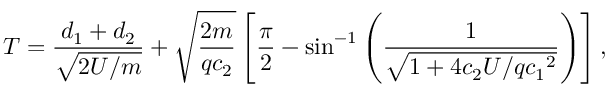Convert formula to latex. <formula><loc_0><loc_0><loc_500><loc_500>T = \frac { d _ { 1 } + d _ { 2 } } { \sqrt { 2 U / m } } + \sqrt { \frac { 2 m } { q c _ { 2 } } } \left [ \frac { \pi } { 2 } - \sin ^ { - 1 } \left ( \frac { 1 } { \sqrt { 1 + 4 c _ { 2 } U / q { c _ { 1 } } ^ { 2 } } } \right ) \right ] ,</formula> 